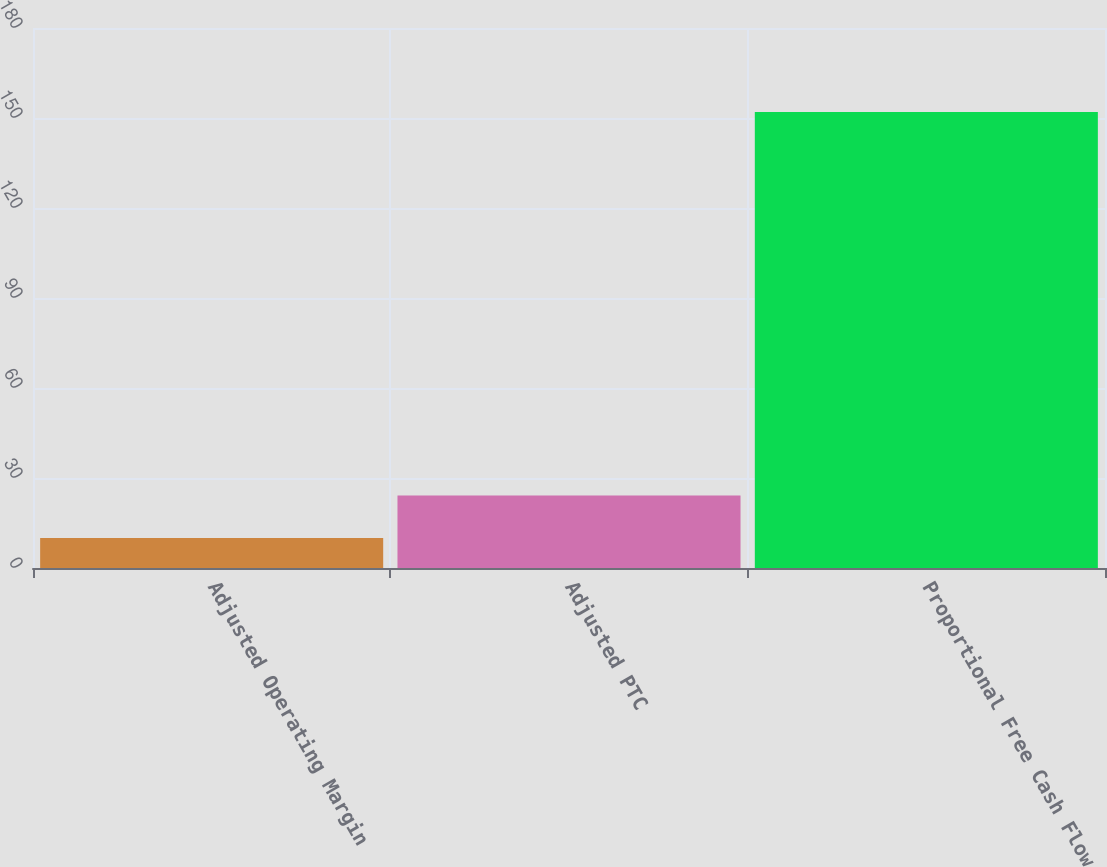<chart> <loc_0><loc_0><loc_500><loc_500><bar_chart><fcel>Adjusted Operating Margin<fcel>Adjusted PTC<fcel>Proportional Free Cash Flow<nl><fcel>10<fcel>24.2<fcel>152<nl></chart> 